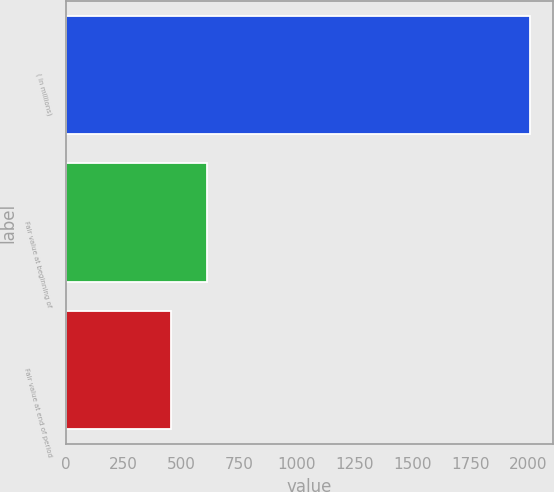<chart> <loc_0><loc_0><loc_500><loc_500><bar_chart><fcel>( in millions)<fcel>Fair value at beginning of<fcel>Fair value at end of period<nl><fcel>2008<fcel>613<fcel>458<nl></chart> 